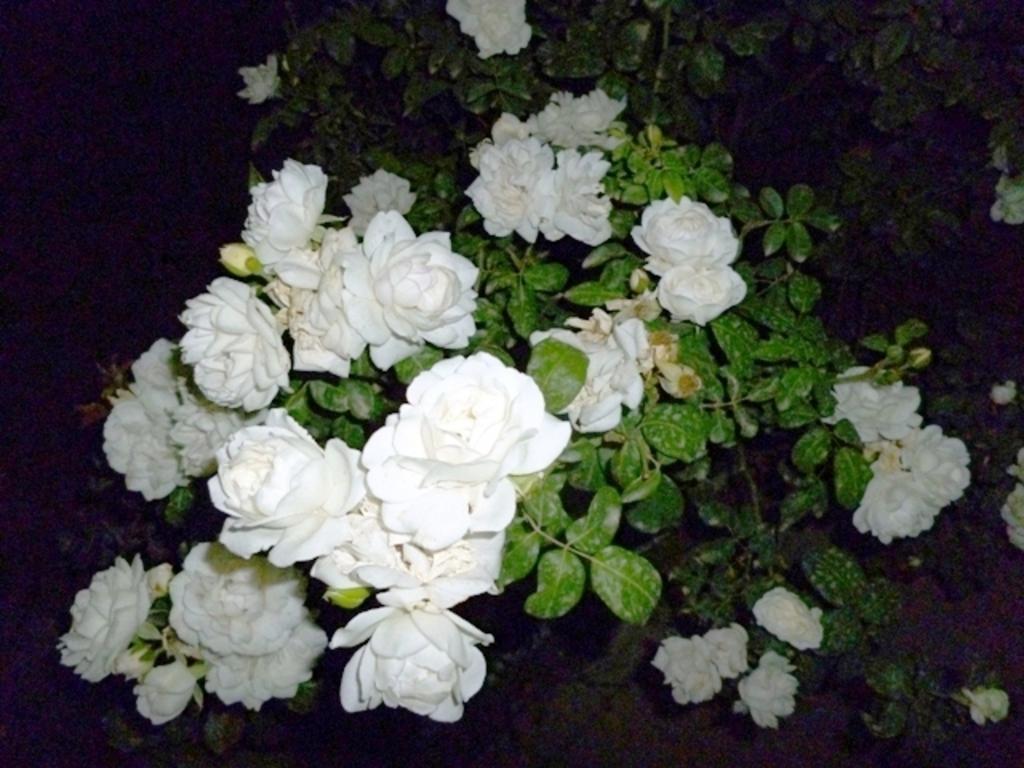Describe this image in one or two sentences. We can see plants, flowers and buds. In the background it is dark. 